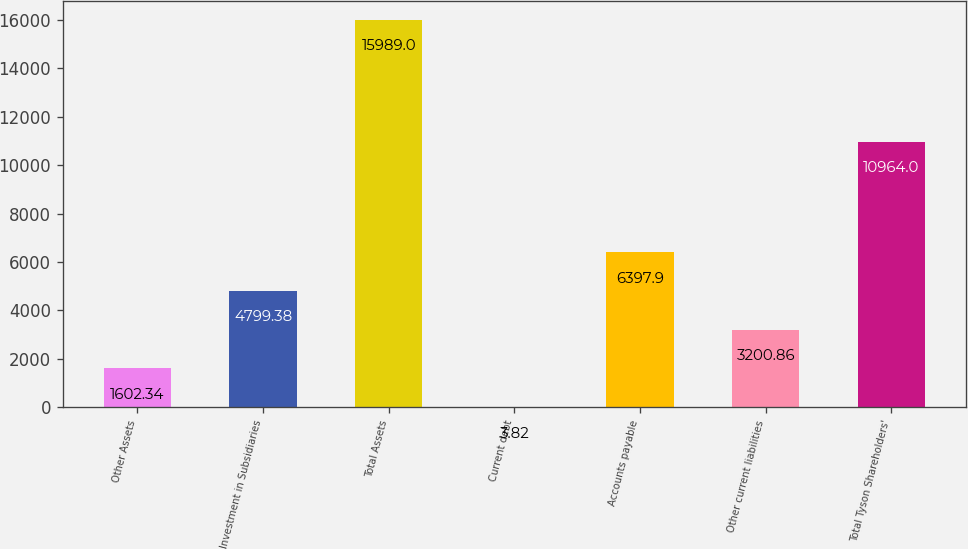Convert chart to OTSL. <chart><loc_0><loc_0><loc_500><loc_500><bar_chart><fcel>Other Assets<fcel>Investment in Subsidiaries<fcel>Total Assets<fcel>Current debt<fcel>Accounts payable<fcel>Other current liabilities<fcel>Total Tyson Shareholders'<nl><fcel>1602.34<fcel>4799.38<fcel>15989<fcel>3.82<fcel>6397.9<fcel>3200.86<fcel>10964<nl></chart> 